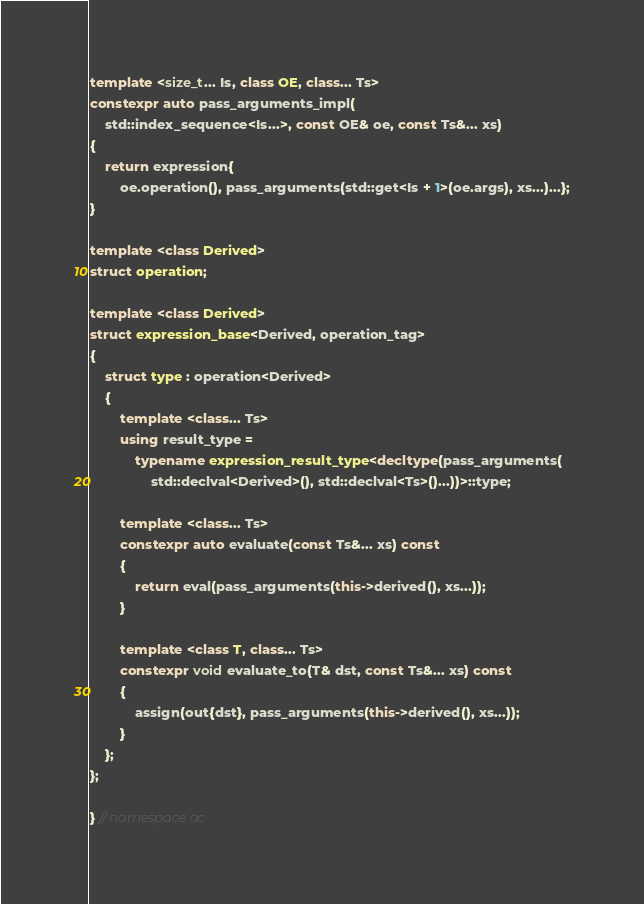Convert code to text. <code><loc_0><loc_0><loc_500><loc_500><_C++_>template <size_t... Is, class OE, class... Ts>
constexpr auto pass_arguments_impl(
    std::index_sequence<Is...>, const OE& oe, const Ts&... xs)
{
    return expression{
        oe.operation(), pass_arguments(std::get<Is + 1>(oe.args), xs...)...};
}

template <class Derived>
struct operation;

template <class Derived>
struct expression_base<Derived, operation_tag>
{
    struct type : operation<Derived>
    {
        template <class... Ts>
        using result_type =
            typename expression_result_type<decltype(pass_arguments(
                std::declval<Derived>(), std::declval<Ts>()...))>::type;

        template <class... Ts>
        constexpr auto evaluate(const Ts&... xs) const
        {
            return eval(pass_arguments(this->derived(), xs...));
        }

        template <class T, class... Ts>
        constexpr void evaluate_to(T& dst, const Ts&... xs) const
        {
            assign(out{dst}, pass_arguments(this->derived(), xs...));
        }
    };
};

} // namespace ac
</code> 